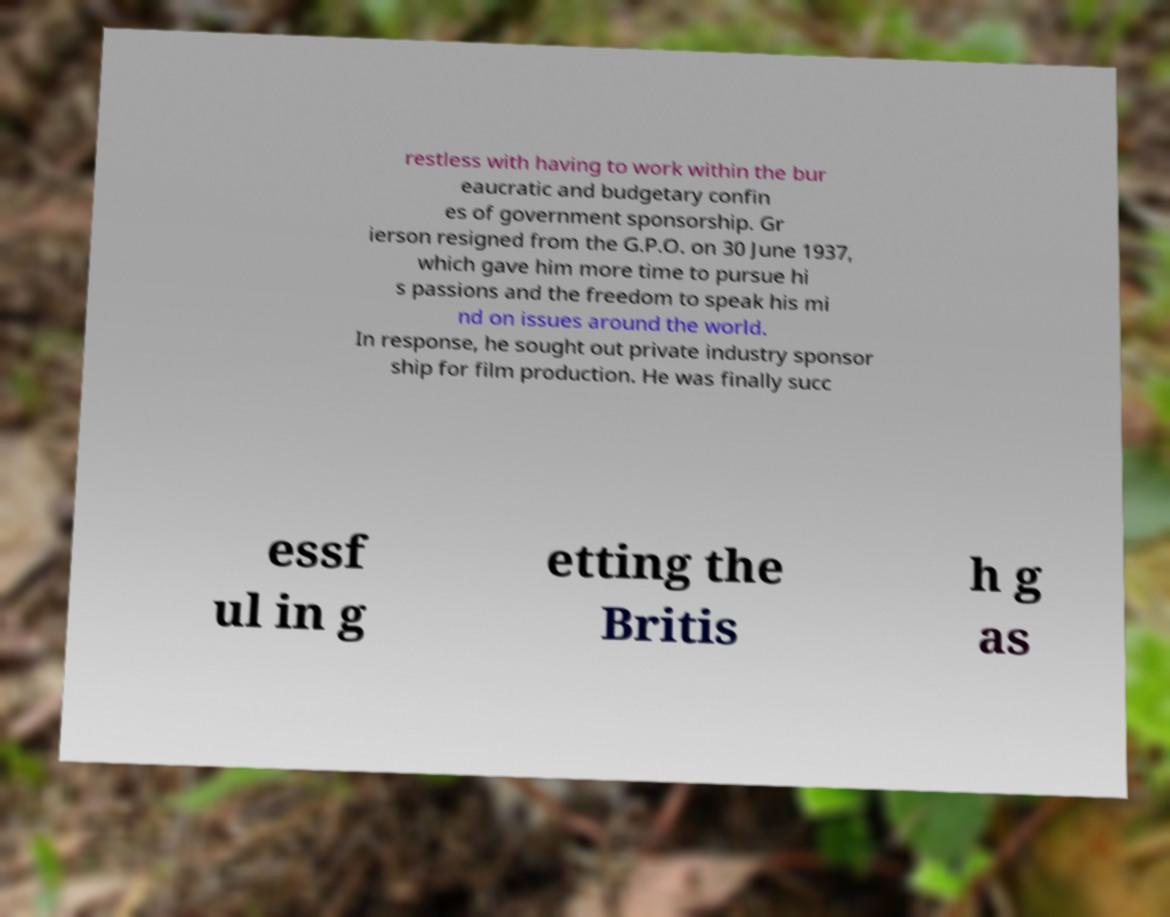Please identify and transcribe the text found in this image. restless with having to work within the bur eaucratic and budgetary confin es of government sponsorship. Gr ierson resigned from the G.P.O. on 30 June 1937, which gave him more time to pursue hi s passions and the freedom to speak his mi nd on issues around the world. In response, he sought out private industry sponsor ship for film production. He was finally succ essf ul in g etting the Britis h g as 